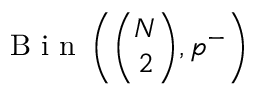Convert formula to latex. <formula><loc_0><loc_0><loc_500><loc_500>B i n \left ( \binom { N } { 2 } , p ^ { - } \right )</formula> 